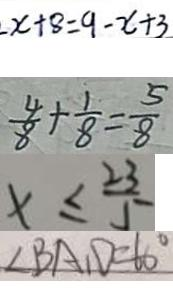Convert formula to latex. <formula><loc_0><loc_0><loc_500><loc_500>x + 8 = 9 - x + 3 
 \frac { 4 } { 8 } + \frac { 1 } { 8 } = \frac { 5 } { 8 } 
 x \leq \frac { 2 3 } { 5 } 
 \angle B A D = 6 0 ^ { \circ }</formula> 